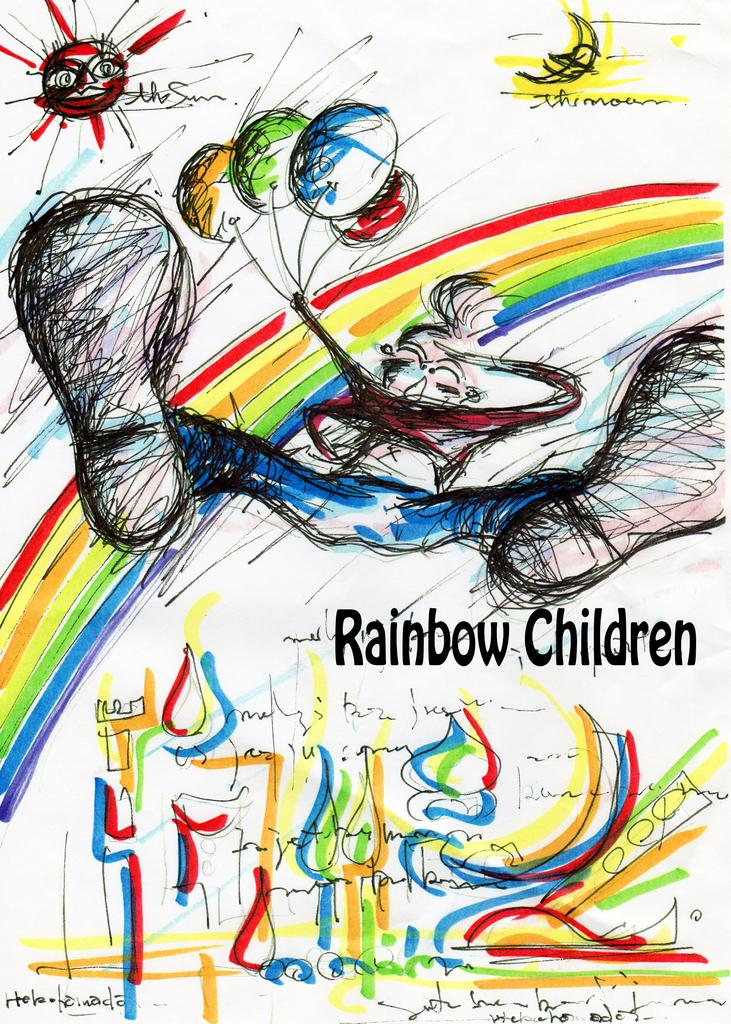What is the main subject of the image? There is an advertisement in the image. What color is the blood on the orange in the image? There is no orange or blood present in the image; it only features an advertisement. 